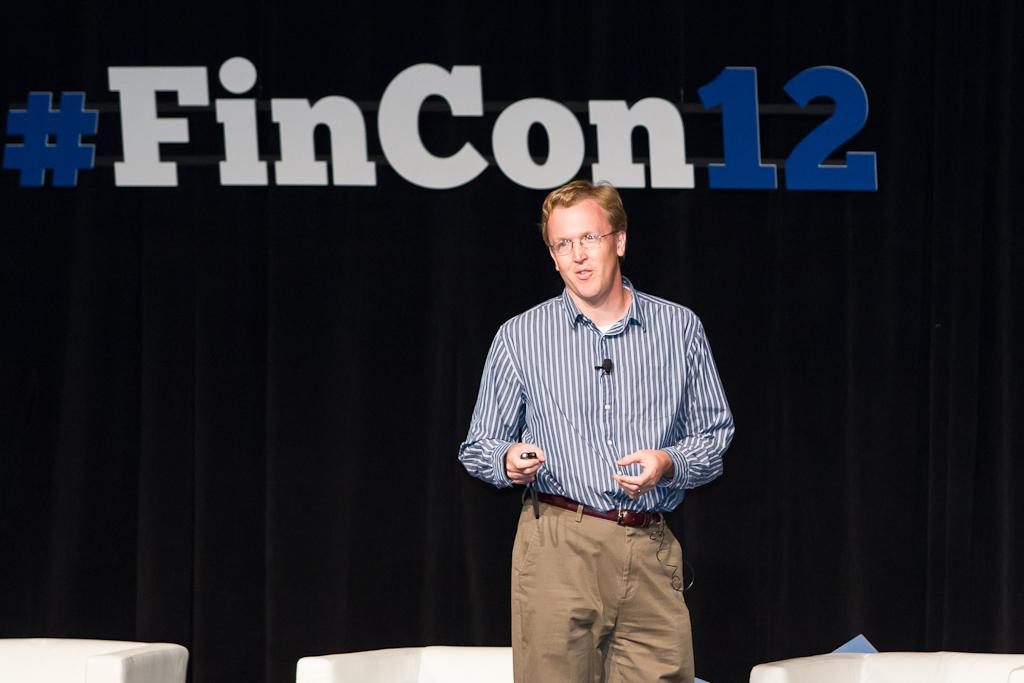Who is the main subject in the image? There is a man in the image. What is the man wearing? The man is wearing a blue shirt and brown pants. What is the man doing in the image? The man is giving a speech on a stage. What can be seen behind the stage? There is a black curtain behind the stage. What type of milk is being poured into the bottle on the stage? There is no milk or bottle present in the image; the man is giving a speech on a stage with a black curtain behind it. 